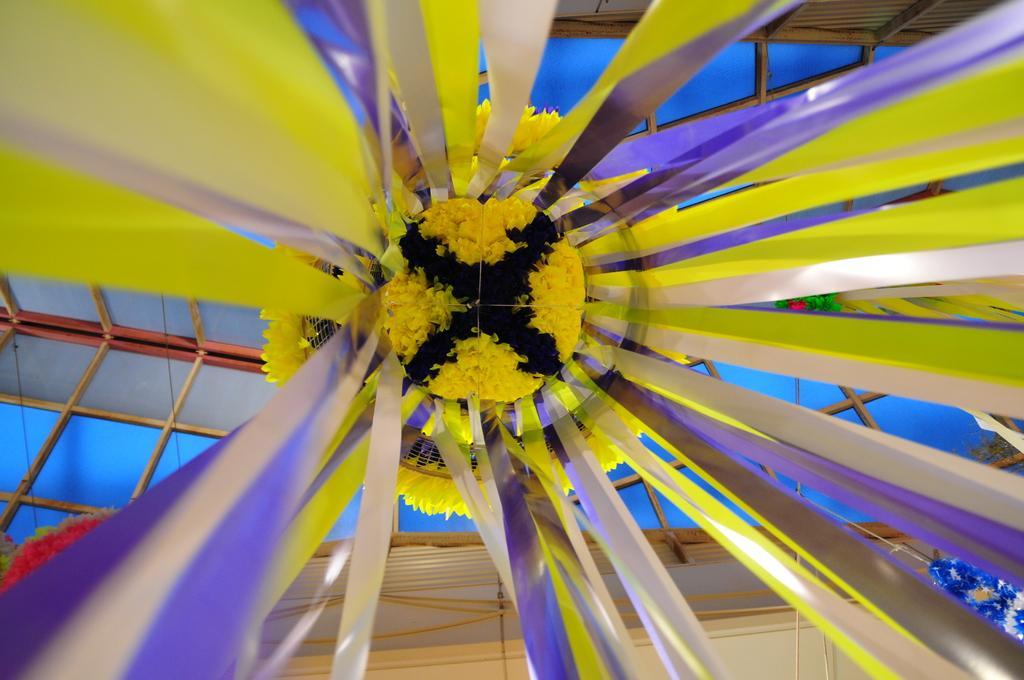In one or two sentences, can you explain what this image depicts? In the foreground of the picture there are ribbons. In the center of the picture we can see flowers to the ceiling. At the top towards left and right it is ceiling covered with glass. 